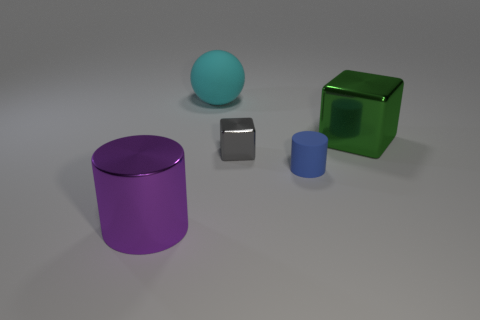The gray metal object has what size? The gray metal object is relatively small, approximately the size of a standard paperweight. Given the context of the image with other objects around, it can be placed in the category of small desktop items. 